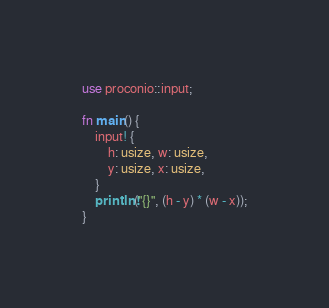<code> <loc_0><loc_0><loc_500><loc_500><_Rust_>use proconio::input;

fn main() {
    input! {
        h: usize, w: usize,
        y: usize, x: usize,
    }
    println!("{}", (h - y) * (w - x));
}
</code> 